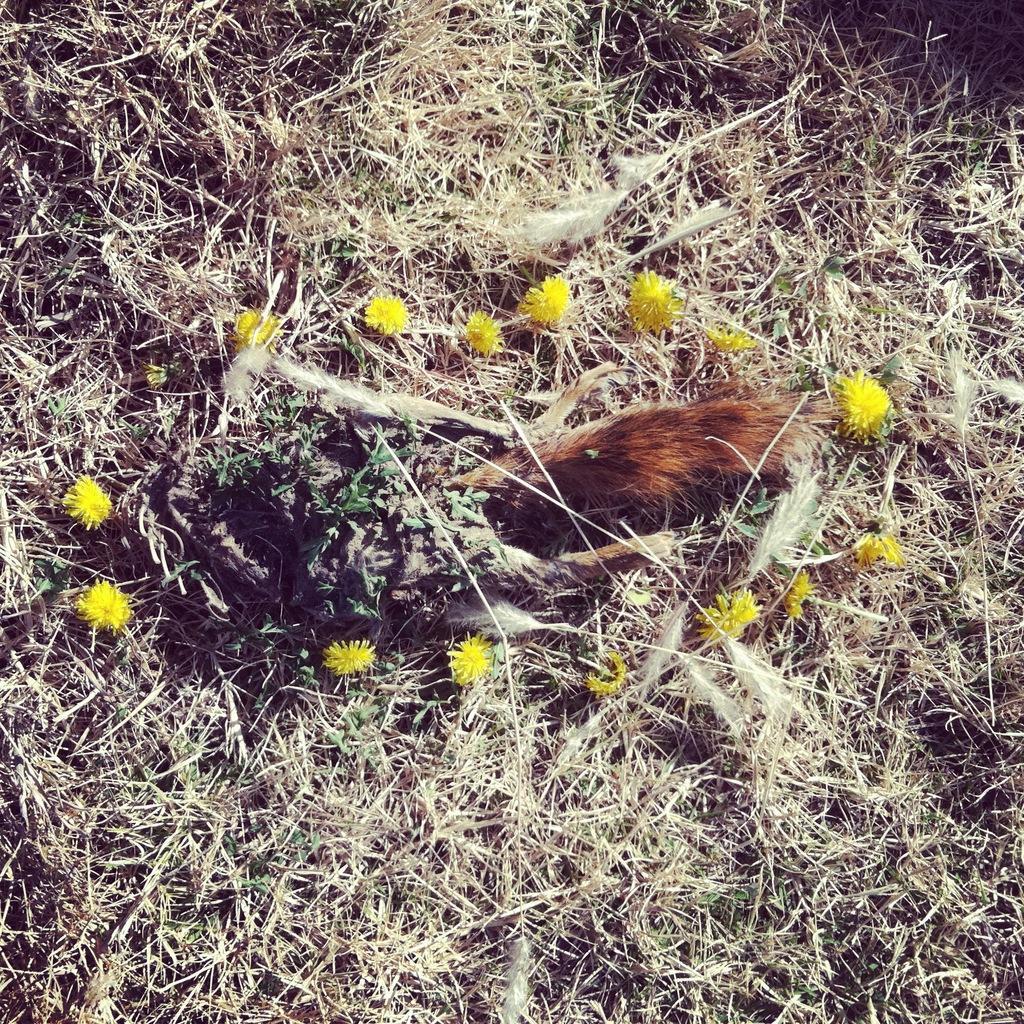Describe this image in one or two sentences. In the foreground of this image, it seems like an animal on the land and we can also see few flowers and the dried grass around it. 